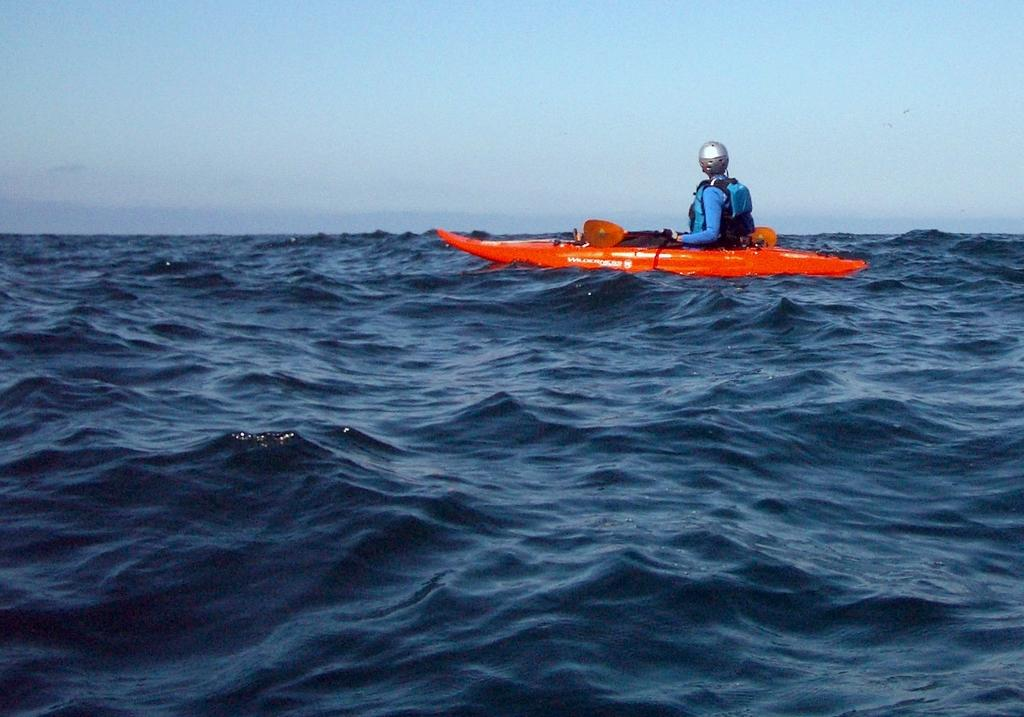What is the person in the image wearing on their head? The person is wearing a helmet in the image. What is the person sitting on in the image? The person is sitting on a boat in the image. Where is the boat located in the image? The boat is on the water in the image. What can be seen in the background of the image? There is sky visible in the background of the image. What type of print can be seen on the person's sock in the image? There is no sock visible in the image, and therefore no print can be observed. 